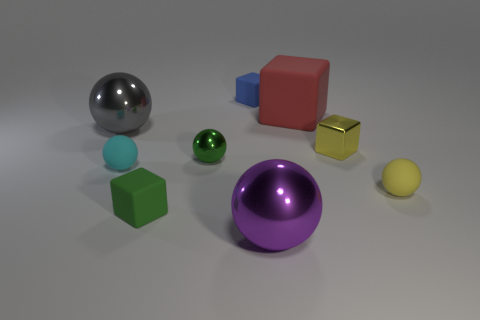What number of objects are either metal balls to the right of the gray metallic sphere or red objects that are on the left side of the yellow block?
Ensure brevity in your answer.  3. Do the tiny cube that is behind the big rubber thing and the large red cube behind the tiny yellow ball have the same material?
Give a very brief answer. Yes. What shape is the yellow thing in front of the small metallic thing that is on the left side of the yellow metallic thing?
Your answer should be compact. Sphere. Are there any other things of the same color as the small metal block?
Give a very brief answer. Yes. Are there any large gray spheres that are in front of the small rubber sphere that is to the left of the tiny rubber block behind the yellow metal block?
Offer a very short reply. No. Is the color of the large sphere in front of the small yellow sphere the same as the big metal ball behind the yellow shiny thing?
Provide a short and direct response. No. What material is the blue block that is the same size as the green matte cube?
Offer a very short reply. Rubber. There is a green matte thing to the right of the large metal ball to the left of the small rubber thing that is behind the tiny metal ball; what is its size?
Offer a very short reply. Small. How many other objects are the same material as the purple thing?
Keep it short and to the point. 3. There is a sphere that is in front of the small yellow matte object; how big is it?
Provide a short and direct response. Large. 